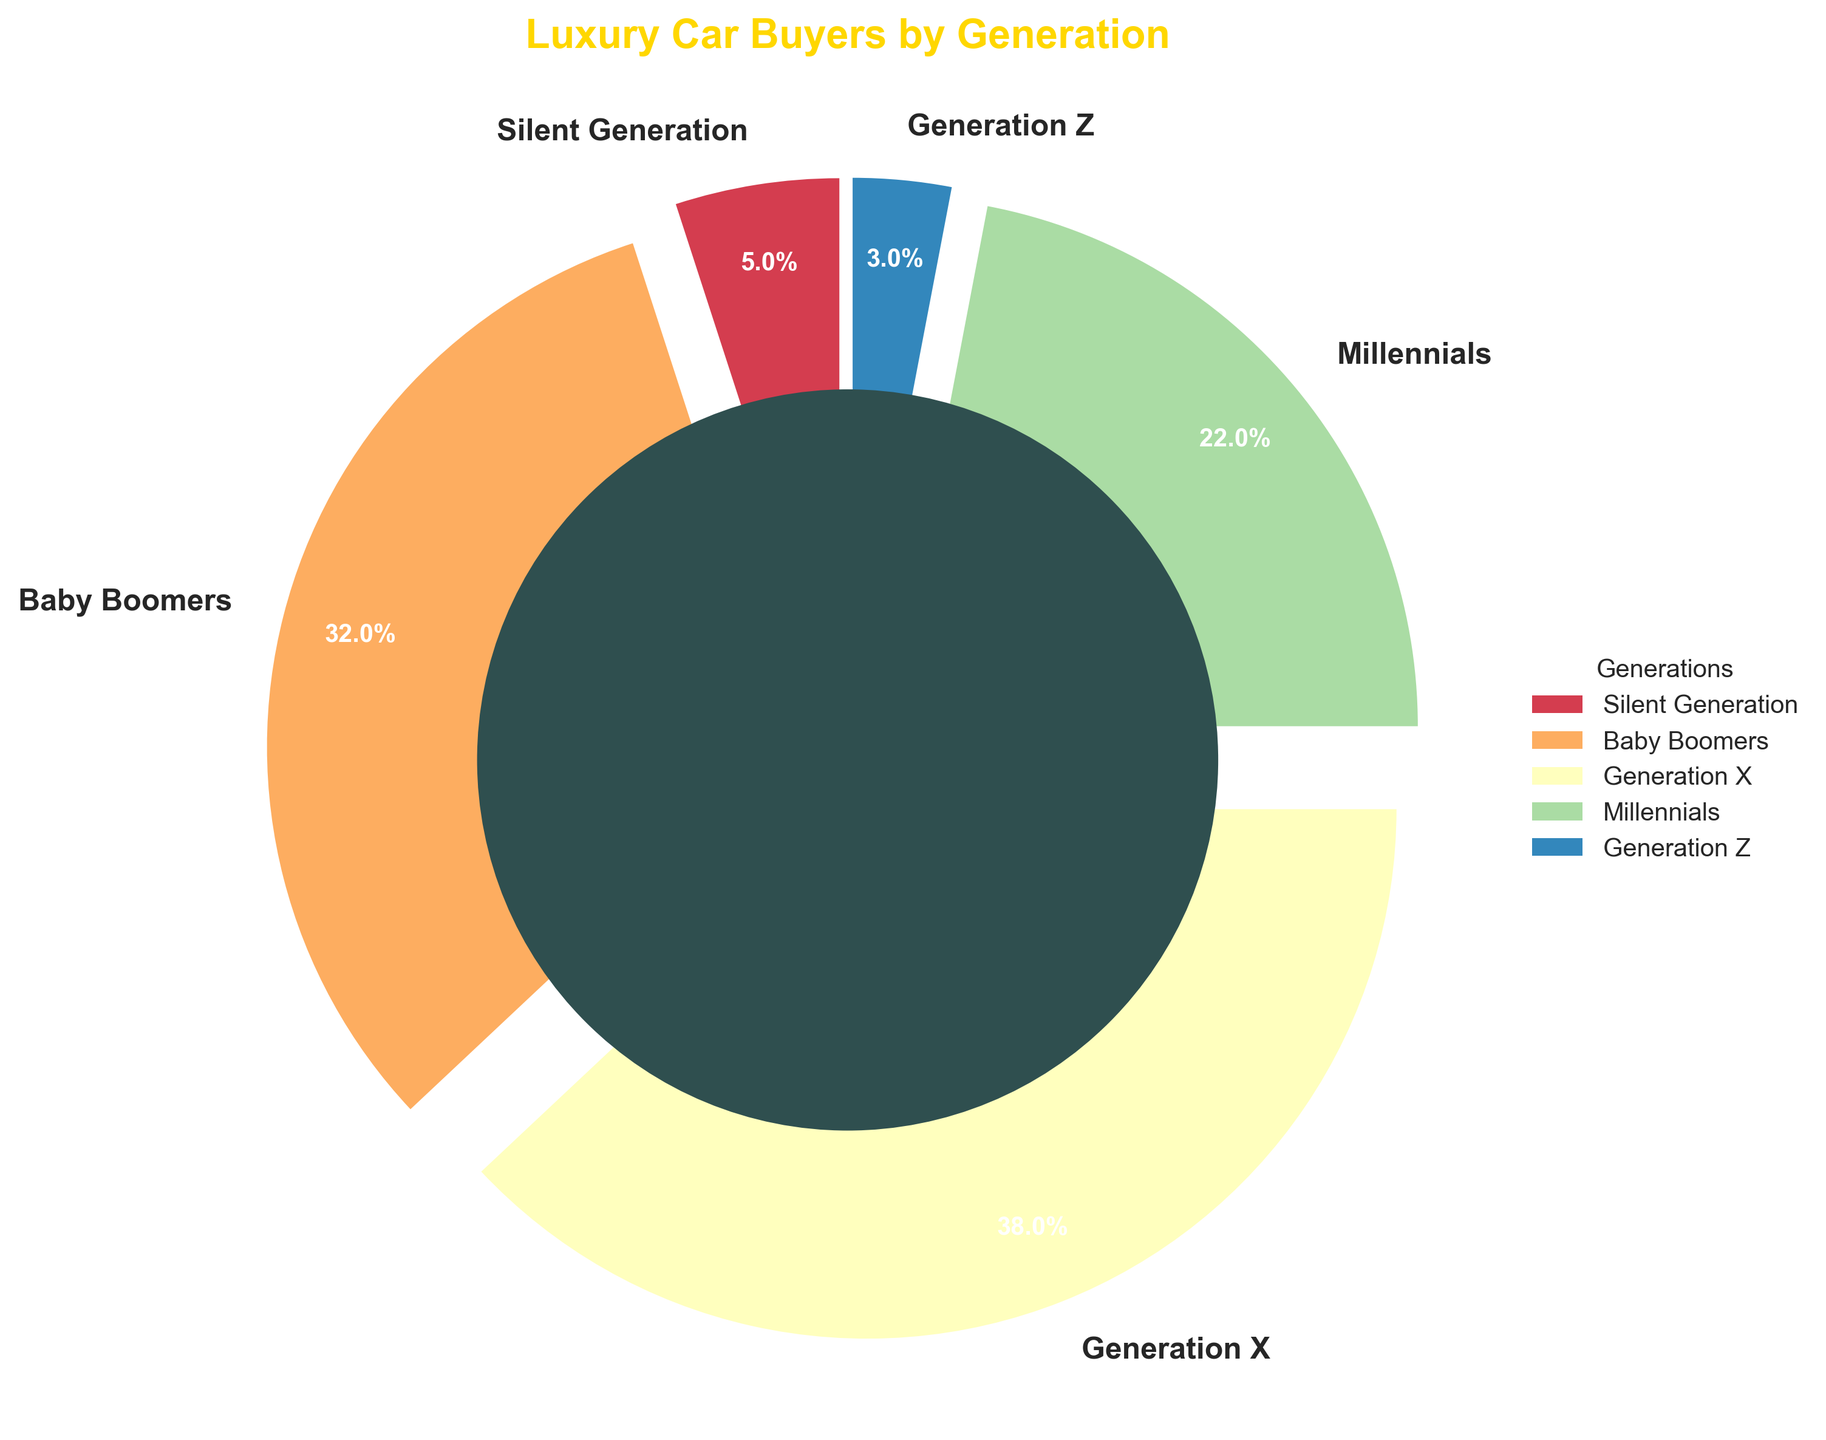Which generation accounts for the largest percentage of luxury car buyers? The pie chart shows the percentage of each generation. Generation X has the largest portion marked as 38%.
Answer: Generation X Which generation accounts for the smallest percentage of luxury car buyers? The pie chart shows the percentage of each generation. Generation Z, with 3%, has the smallest portion.
Answer: Generation Z What is the combined percentage of luxury car buyers from the Millennial and Generation X categories? According to the pie chart, Millennials account for 22% and Generation X accounts for 38%. Adding these percentages together gives 22% + 38% = 60%.
Answer: 60% How does the percentage of Baby Boomers compare to Millennials? The pie chart shows Baby Boomers account for 32% and Millennials account for 22%. Therefore, Baby Boomers have a higher percentage by 32% - 22% = 10%.
Answer: Baby Boomers have 10% more What is the total percentage of luxury car buyers who are from Generation Z and the Silent Generation? The pie chart shows Generation Z at 3% and the Silent Generation at 5%. Adding these percentages gives 3% + 5% = 8%.
Answer: 8% How much larger is the percentage of Generation X buyers compared to Generation Z buyers? The pie chart shows Generation X at 38% and Generation Z at 3%. Therefore, Generation X has a larger percentage by 38% - 3% = 35%.
Answer: 35% What fraction of the total luxury car buyers are Baby Boomers? The pie chart shows Baby Boomers account for 32%. Since percentages can be converted to fractions by dividing by 100, this is 32% / 100 = 0.32 or 32/100 which simplifies to 8/25.
Answer: 8/25 Which generation has the second-largest share of luxury car buyers? The pie chart shows Generation X has the largest share (38%), followed by Baby Boomers who have the next largest at 32%.
Answer: Baby Boomers What is the difference in the combined percentage of Baby Boomers and Generation X compared to the combined percentage of Millennials, Generation Z, and the Silent Generation? The pie chart shows Baby Boomers at 32% and Generation X at 38%, making a combined total of 32% + 38% = 70%. Millennials are at 22%, Generation Z at 3%, and the Silent Generation at 5%, making their combined total 22% + 3% + 5% = 30%. The difference is 70% - 30% = 40%.
Answer: 40% 